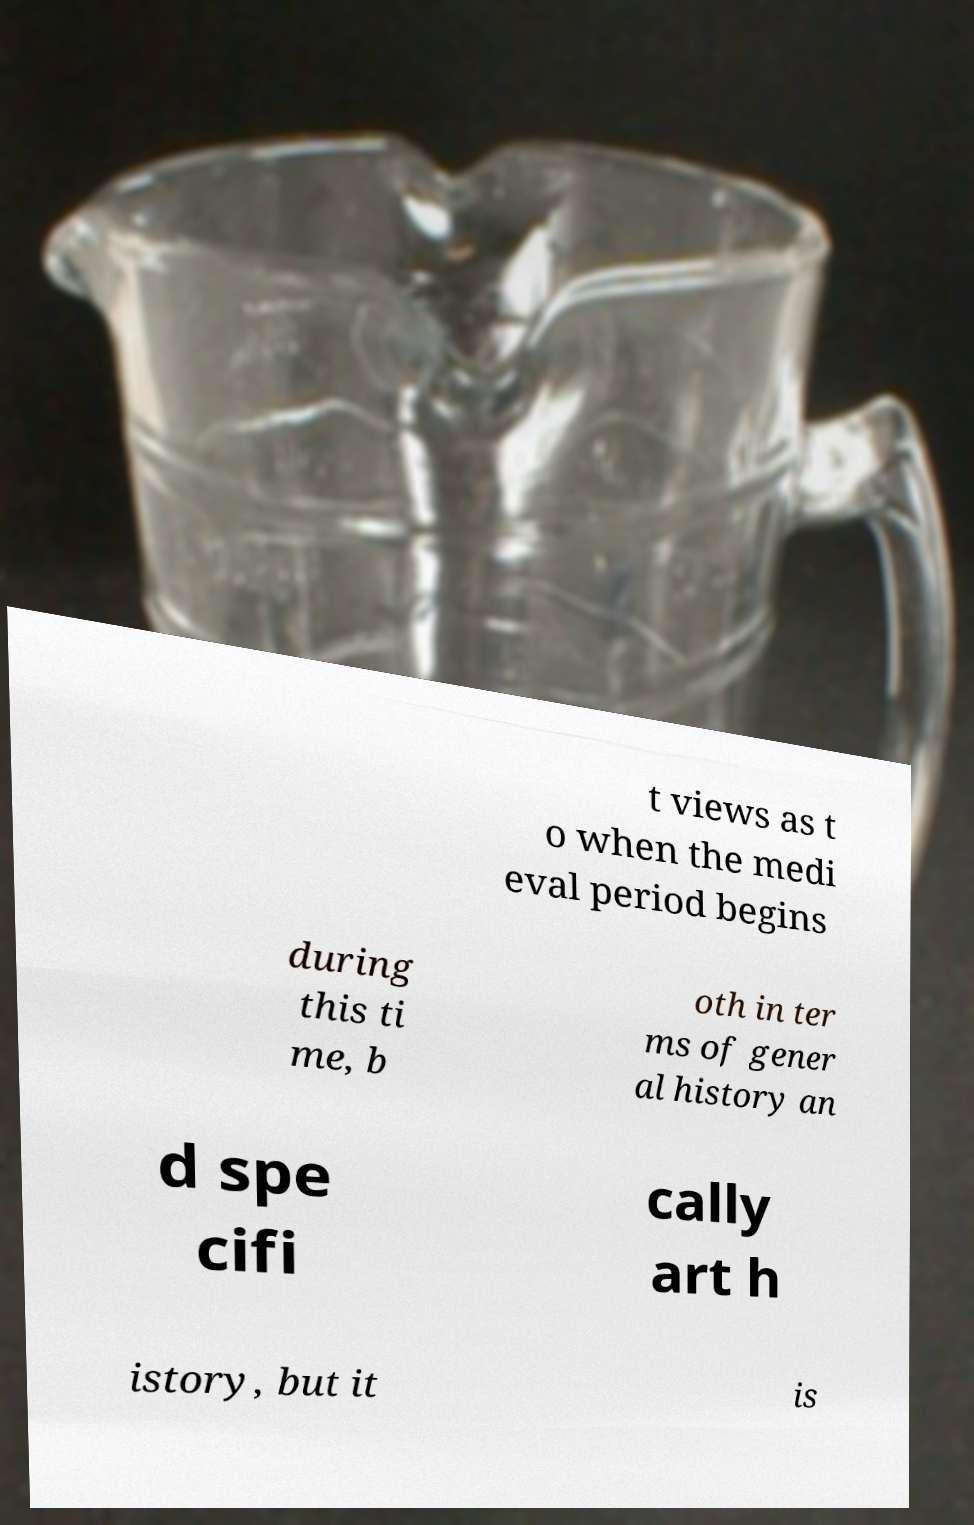What messages or text are displayed in this image? I need them in a readable, typed format. t views as t o when the medi eval period begins during this ti me, b oth in ter ms of gener al history an d spe cifi cally art h istory, but it is 